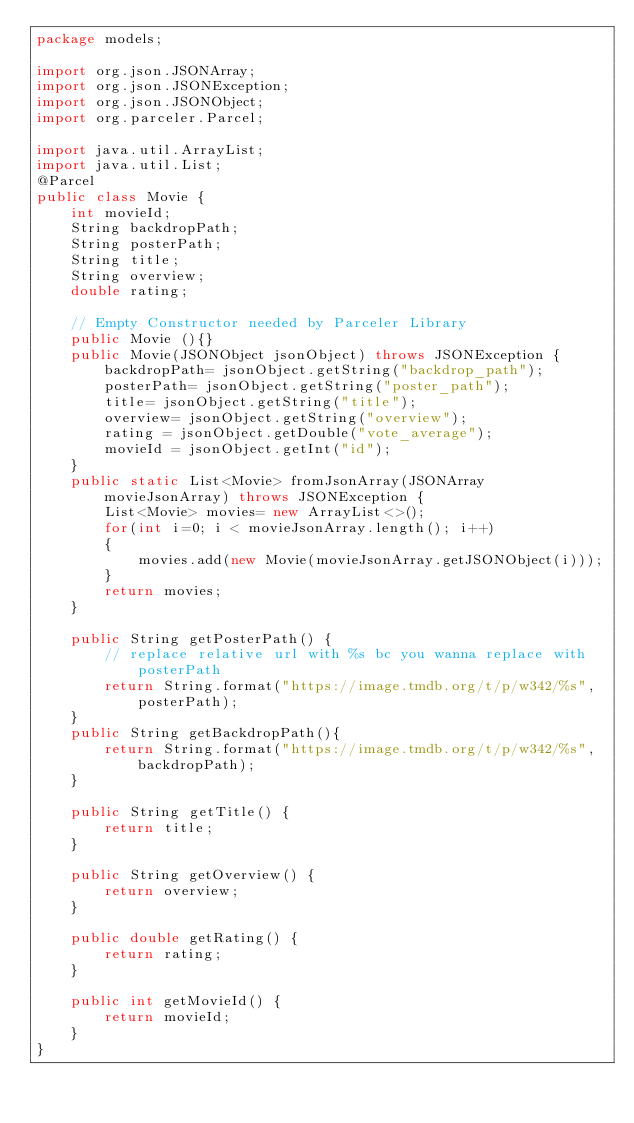Convert code to text. <code><loc_0><loc_0><loc_500><loc_500><_Java_>package models;

import org.json.JSONArray;
import org.json.JSONException;
import org.json.JSONObject;
import org.parceler.Parcel;

import java.util.ArrayList;
import java.util.List;
@Parcel
public class Movie {
    int movieId;
    String backdropPath;
    String posterPath;
    String title;
    String overview;
    double rating;

    // Empty Constructor needed by Parceler Library
    public Movie (){}
    public Movie(JSONObject jsonObject) throws JSONException {
        backdropPath= jsonObject.getString("backdrop_path");
        posterPath= jsonObject.getString("poster_path");
        title= jsonObject.getString("title");
        overview= jsonObject.getString("overview");
        rating = jsonObject.getDouble("vote_average");
        movieId = jsonObject.getInt("id");
    }
    public static List<Movie> fromJsonArray(JSONArray movieJsonArray) throws JSONException {
        List<Movie> movies= new ArrayList<>();
        for(int i=0; i < movieJsonArray.length(); i++)
        {
            movies.add(new Movie(movieJsonArray.getJSONObject(i)));
        }
        return movies;
    }

    public String getPosterPath() {
        // replace relative url with %s bc you wanna replace with posterPath
        return String.format("https://image.tmdb.org/t/p/w342/%s", posterPath);
    }
    public String getBackdropPath(){
        return String.format("https://image.tmdb.org/t/p/w342/%s", backdropPath);
    }

    public String getTitle() {
        return title;
    }

    public String getOverview() {
        return overview;
    }

    public double getRating() {
        return rating;
    }

    public int getMovieId() {
        return movieId;
    }
}
</code> 